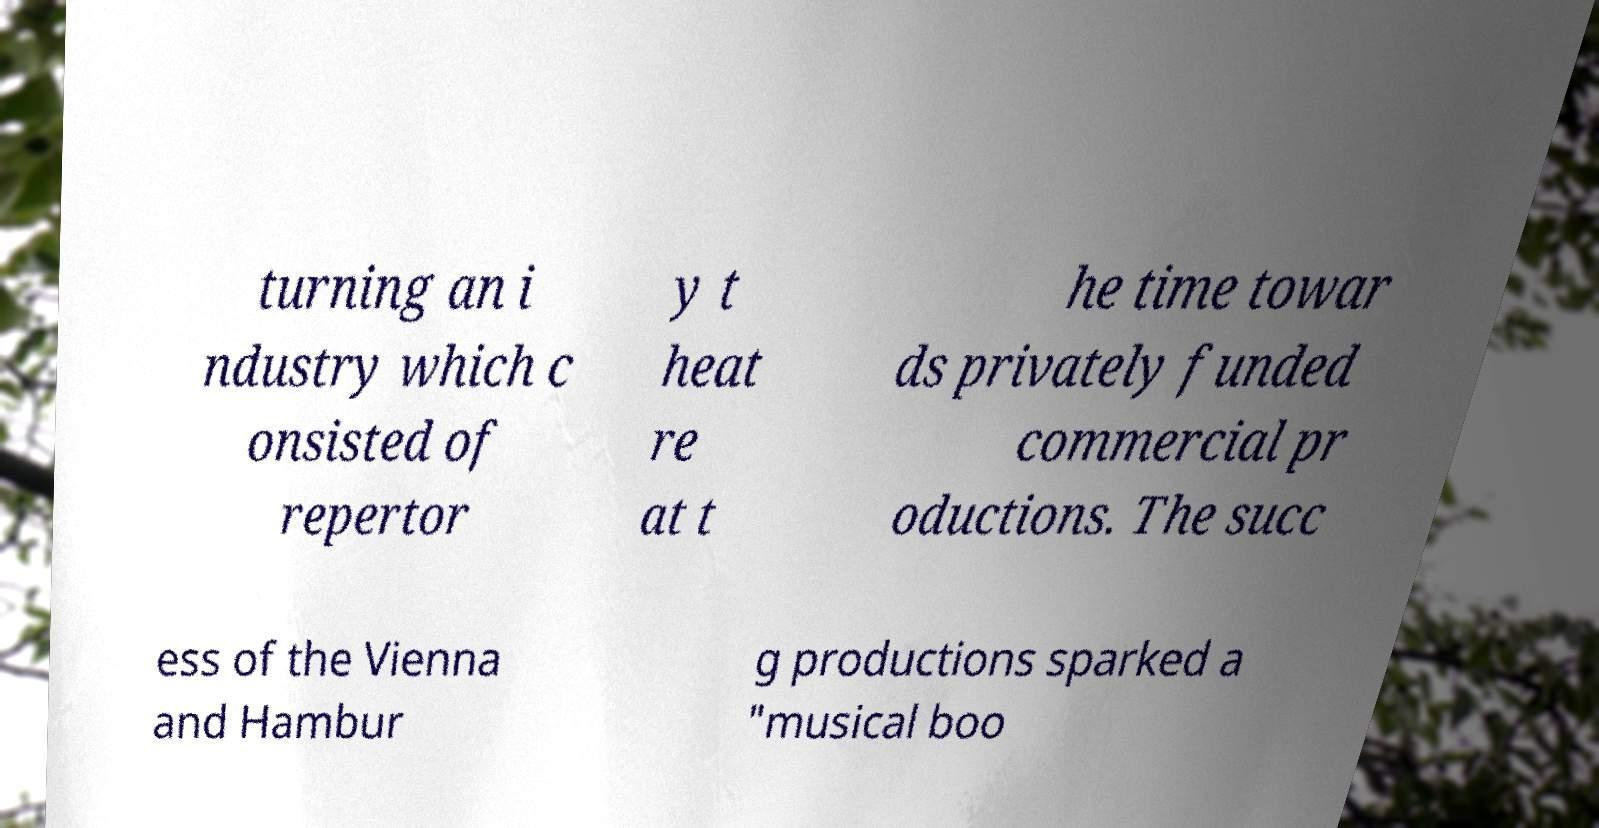I need the written content from this picture converted into text. Can you do that? turning an i ndustry which c onsisted of repertor y t heat re at t he time towar ds privately funded commercial pr oductions. The succ ess of the Vienna and Hambur g productions sparked a "musical boo 